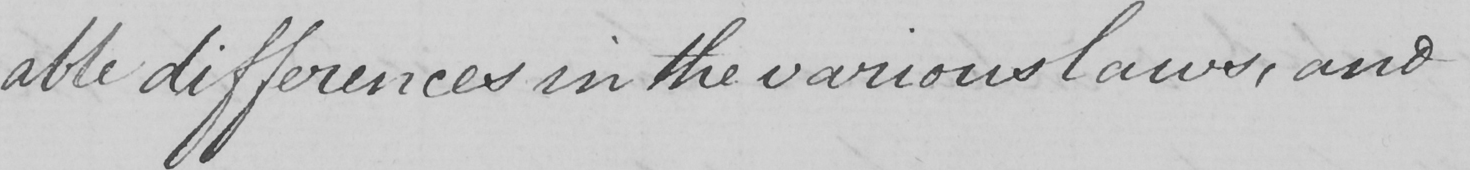Please transcribe the handwritten text in this image. -able differences in the various laws , and 